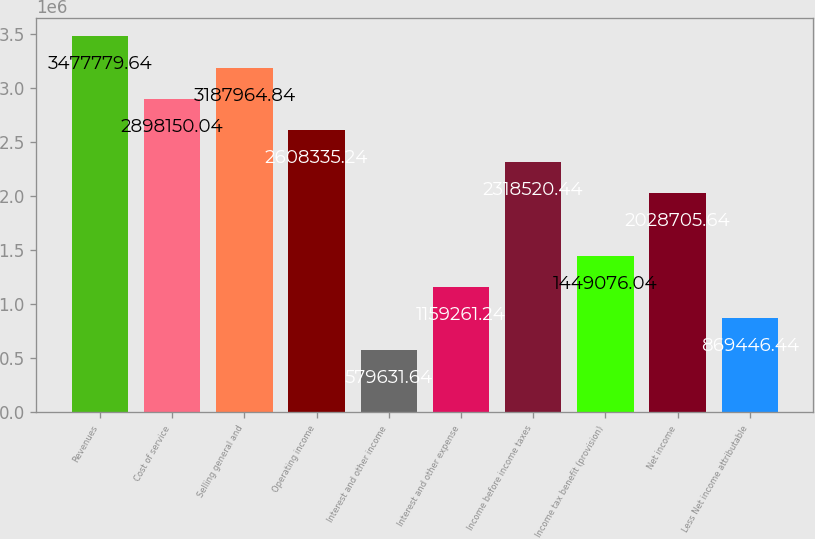Convert chart to OTSL. <chart><loc_0><loc_0><loc_500><loc_500><bar_chart><fcel>Revenues<fcel>Cost of service<fcel>Selling general and<fcel>Operating income<fcel>Interest and other income<fcel>Interest and other expense<fcel>Income before income taxes<fcel>Income tax benefit (provision)<fcel>Net income<fcel>Less Net income attributable<nl><fcel>3.47778e+06<fcel>2.89815e+06<fcel>3.18796e+06<fcel>2.60834e+06<fcel>579632<fcel>1.15926e+06<fcel>2.31852e+06<fcel>1.44908e+06<fcel>2.02871e+06<fcel>869446<nl></chart> 